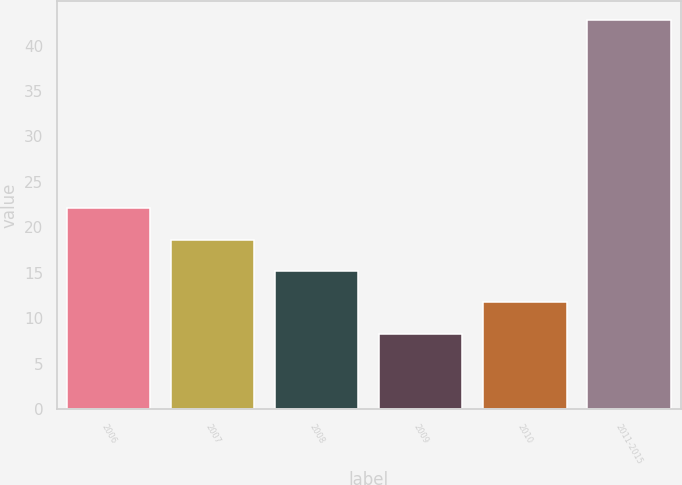Convert chart. <chart><loc_0><loc_0><loc_500><loc_500><bar_chart><fcel>2006<fcel>2007<fcel>2008<fcel>2009<fcel>2010<fcel>2011-2015<nl><fcel>22.1<fcel>18.65<fcel>15.2<fcel>8.3<fcel>11.75<fcel>42.8<nl></chart> 